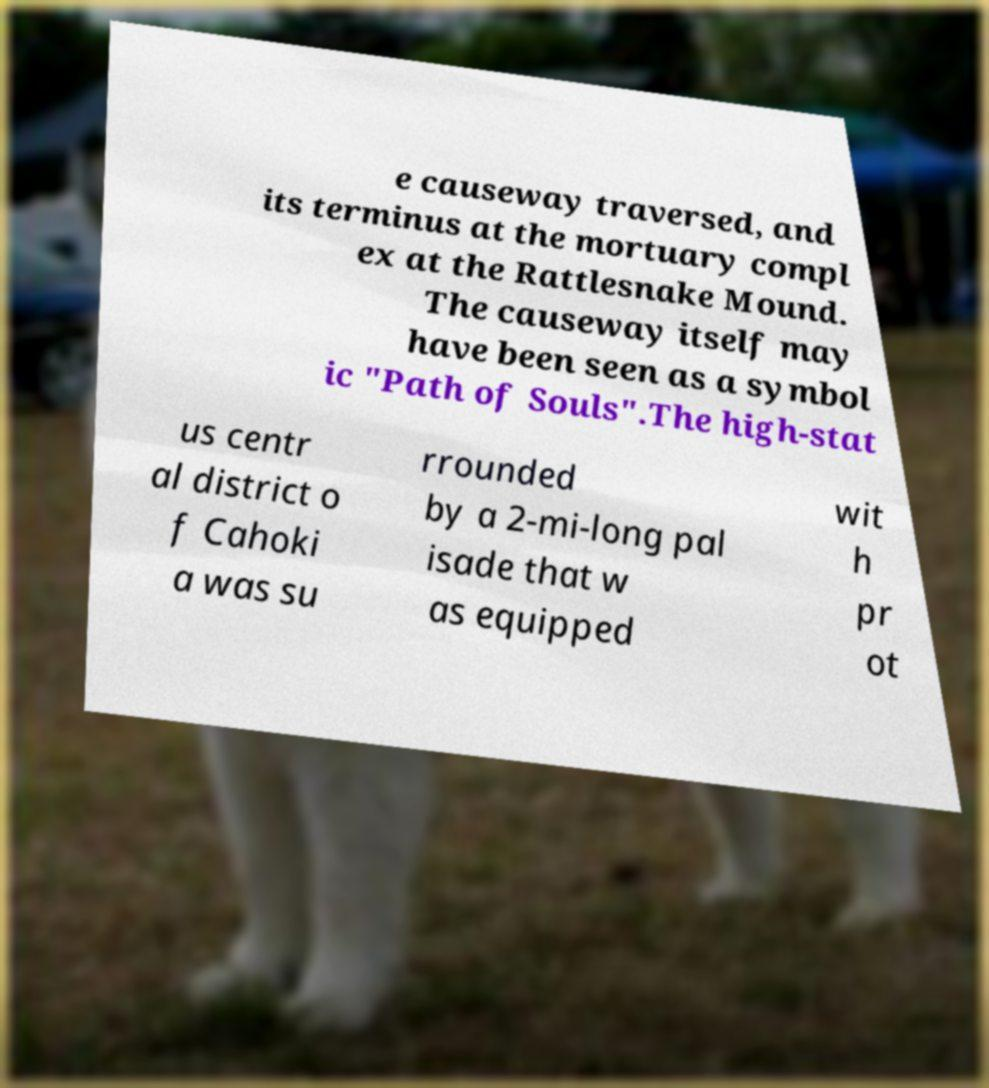Can you read and provide the text displayed in the image?This photo seems to have some interesting text. Can you extract and type it out for me? e causeway traversed, and its terminus at the mortuary compl ex at the Rattlesnake Mound. The causeway itself may have been seen as a symbol ic "Path of Souls".The high-stat us centr al district o f Cahoki a was su rrounded by a 2-mi-long pal isade that w as equipped wit h pr ot 